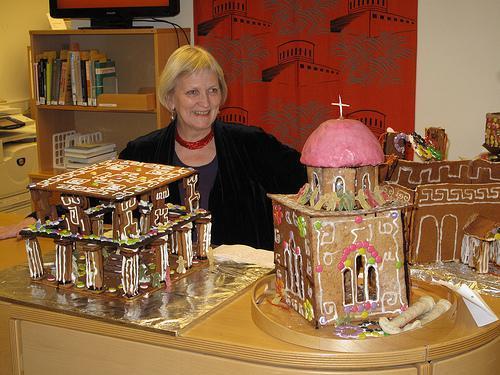How many people are pictured?
Give a very brief answer. 1. How many gingerbread houses are there?
Give a very brief answer. 3. 